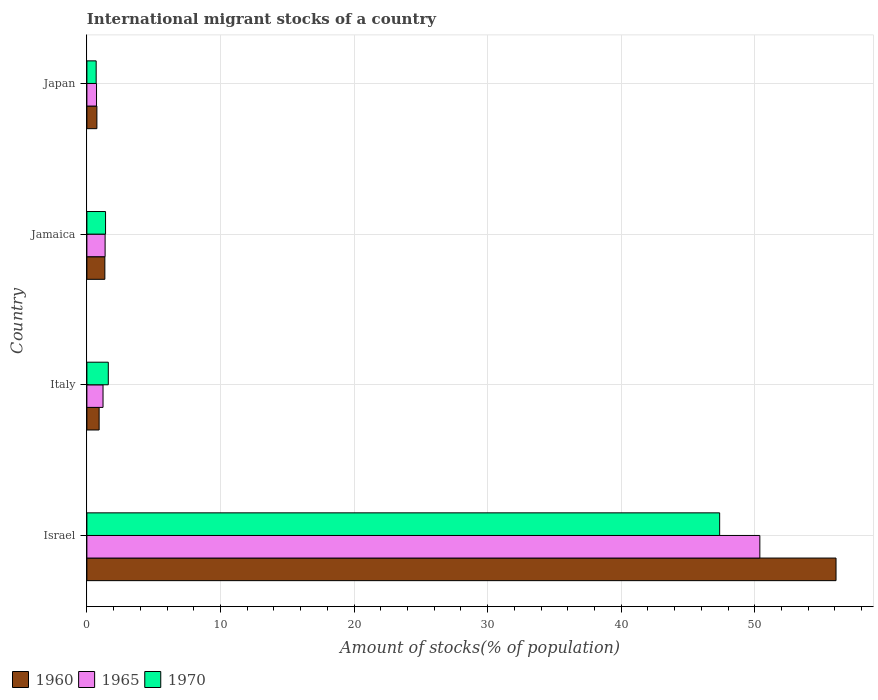How many different coloured bars are there?
Make the answer very short. 3. How many bars are there on the 2nd tick from the top?
Give a very brief answer. 3. How many bars are there on the 2nd tick from the bottom?
Make the answer very short. 3. What is the amount of stocks in in 1970 in Jamaica?
Offer a terse response. 1.4. Across all countries, what is the maximum amount of stocks in in 1965?
Offer a terse response. 50.38. Across all countries, what is the minimum amount of stocks in in 1970?
Provide a succinct answer. 0.69. In which country was the amount of stocks in in 1965 minimum?
Offer a very short reply. Japan. What is the total amount of stocks in in 1970 in the graph?
Offer a very short reply. 51.06. What is the difference between the amount of stocks in in 1970 in Italy and that in Jamaica?
Offer a terse response. 0.21. What is the difference between the amount of stocks in in 1965 in Italy and the amount of stocks in in 1970 in Jamaica?
Offer a very short reply. -0.19. What is the average amount of stocks in in 1960 per country?
Make the answer very short. 14.77. What is the difference between the amount of stocks in in 1965 and amount of stocks in in 1970 in Italy?
Offer a very short reply. -0.39. What is the ratio of the amount of stocks in in 1970 in Italy to that in Japan?
Give a very brief answer. 2.31. Is the difference between the amount of stocks in in 1965 in Italy and Japan greater than the difference between the amount of stocks in in 1970 in Italy and Japan?
Keep it short and to the point. No. What is the difference between the highest and the second highest amount of stocks in in 1970?
Provide a short and direct response. 45.77. What is the difference between the highest and the lowest amount of stocks in in 1965?
Your answer should be very brief. 49.66. Is the sum of the amount of stocks in in 1965 in Italy and Jamaica greater than the maximum amount of stocks in in 1960 across all countries?
Offer a terse response. No. What does the 1st bar from the bottom in Israel represents?
Provide a short and direct response. 1960. Is it the case that in every country, the sum of the amount of stocks in in 1965 and amount of stocks in in 1970 is greater than the amount of stocks in in 1960?
Keep it short and to the point. Yes. What is the difference between two consecutive major ticks on the X-axis?
Give a very brief answer. 10. Are the values on the major ticks of X-axis written in scientific E-notation?
Your response must be concise. No. Does the graph contain any zero values?
Make the answer very short. No. Does the graph contain grids?
Give a very brief answer. Yes. Where does the legend appear in the graph?
Offer a terse response. Bottom left. How many legend labels are there?
Make the answer very short. 3. How are the legend labels stacked?
Your response must be concise. Horizontal. What is the title of the graph?
Your response must be concise. International migrant stocks of a country. What is the label or title of the X-axis?
Offer a terse response. Amount of stocks(% of population). What is the Amount of stocks(% of population) of 1960 in Israel?
Your answer should be very brief. 56.08. What is the Amount of stocks(% of population) in 1965 in Israel?
Your answer should be very brief. 50.38. What is the Amount of stocks(% of population) in 1970 in Israel?
Make the answer very short. 47.37. What is the Amount of stocks(% of population) in 1960 in Italy?
Provide a succinct answer. 0.92. What is the Amount of stocks(% of population) in 1965 in Italy?
Your answer should be compact. 1.21. What is the Amount of stocks(% of population) of 1970 in Italy?
Your answer should be compact. 1.6. What is the Amount of stocks(% of population) in 1960 in Jamaica?
Your answer should be very brief. 1.34. What is the Amount of stocks(% of population) in 1965 in Jamaica?
Ensure brevity in your answer.  1.36. What is the Amount of stocks(% of population) in 1970 in Jamaica?
Offer a very short reply. 1.4. What is the Amount of stocks(% of population) in 1960 in Japan?
Offer a terse response. 0.75. What is the Amount of stocks(% of population) in 1965 in Japan?
Keep it short and to the point. 0.72. What is the Amount of stocks(% of population) of 1970 in Japan?
Your answer should be very brief. 0.69. Across all countries, what is the maximum Amount of stocks(% of population) in 1960?
Ensure brevity in your answer.  56.08. Across all countries, what is the maximum Amount of stocks(% of population) in 1965?
Provide a succinct answer. 50.38. Across all countries, what is the maximum Amount of stocks(% of population) of 1970?
Your response must be concise. 47.37. Across all countries, what is the minimum Amount of stocks(% of population) of 1960?
Your answer should be very brief. 0.75. Across all countries, what is the minimum Amount of stocks(% of population) in 1965?
Your answer should be compact. 0.72. Across all countries, what is the minimum Amount of stocks(% of population) of 1970?
Provide a short and direct response. 0.69. What is the total Amount of stocks(% of population) of 1960 in the graph?
Your answer should be very brief. 59.09. What is the total Amount of stocks(% of population) in 1965 in the graph?
Your answer should be very brief. 53.67. What is the total Amount of stocks(% of population) of 1970 in the graph?
Your answer should be compact. 51.06. What is the difference between the Amount of stocks(% of population) of 1960 in Israel and that in Italy?
Provide a short and direct response. 55.17. What is the difference between the Amount of stocks(% of population) of 1965 in Israel and that in Italy?
Your answer should be compact. 49.17. What is the difference between the Amount of stocks(% of population) of 1970 in Israel and that in Italy?
Offer a terse response. 45.77. What is the difference between the Amount of stocks(% of population) in 1960 in Israel and that in Jamaica?
Make the answer very short. 54.74. What is the difference between the Amount of stocks(% of population) in 1965 in Israel and that in Jamaica?
Give a very brief answer. 49.01. What is the difference between the Amount of stocks(% of population) in 1970 in Israel and that in Jamaica?
Offer a very short reply. 45.97. What is the difference between the Amount of stocks(% of population) in 1960 in Israel and that in Japan?
Keep it short and to the point. 55.33. What is the difference between the Amount of stocks(% of population) in 1965 in Israel and that in Japan?
Offer a terse response. 49.66. What is the difference between the Amount of stocks(% of population) in 1970 in Israel and that in Japan?
Ensure brevity in your answer.  46.67. What is the difference between the Amount of stocks(% of population) of 1960 in Italy and that in Jamaica?
Provide a succinct answer. -0.43. What is the difference between the Amount of stocks(% of population) of 1965 in Italy and that in Jamaica?
Keep it short and to the point. -0.16. What is the difference between the Amount of stocks(% of population) of 1970 in Italy and that in Jamaica?
Provide a succinct answer. 0.21. What is the difference between the Amount of stocks(% of population) of 1960 in Italy and that in Japan?
Offer a very short reply. 0.17. What is the difference between the Amount of stocks(% of population) of 1965 in Italy and that in Japan?
Your answer should be very brief. 0.49. What is the difference between the Amount of stocks(% of population) of 1970 in Italy and that in Japan?
Ensure brevity in your answer.  0.91. What is the difference between the Amount of stocks(% of population) of 1960 in Jamaica and that in Japan?
Provide a succinct answer. 0.6. What is the difference between the Amount of stocks(% of population) in 1965 in Jamaica and that in Japan?
Offer a terse response. 0.64. What is the difference between the Amount of stocks(% of population) of 1970 in Jamaica and that in Japan?
Keep it short and to the point. 0.7. What is the difference between the Amount of stocks(% of population) in 1960 in Israel and the Amount of stocks(% of population) in 1965 in Italy?
Provide a short and direct response. 54.87. What is the difference between the Amount of stocks(% of population) of 1960 in Israel and the Amount of stocks(% of population) of 1970 in Italy?
Offer a very short reply. 54.48. What is the difference between the Amount of stocks(% of population) of 1965 in Israel and the Amount of stocks(% of population) of 1970 in Italy?
Make the answer very short. 48.78. What is the difference between the Amount of stocks(% of population) of 1960 in Israel and the Amount of stocks(% of population) of 1965 in Jamaica?
Offer a terse response. 54.72. What is the difference between the Amount of stocks(% of population) of 1960 in Israel and the Amount of stocks(% of population) of 1970 in Jamaica?
Give a very brief answer. 54.69. What is the difference between the Amount of stocks(% of population) of 1965 in Israel and the Amount of stocks(% of population) of 1970 in Jamaica?
Keep it short and to the point. 48.98. What is the difference between the Amount of stocks(% of population) of 1960 in Israel and the Amount of stocks(% of population) of 1965 in Japan?
Make the answer very short. 55.36. What is the difference between the Amount of stocks(% of population) of 1960 in Israel and the Amount of stocks(% of population) of 1970 in Japan?
Provide a short and direct response. 55.39. What is the difference between the Amount of stocks(% of population) in 1965 in Israel and the Amount of stocks(% of population) in 1970 in Japan?
Make the answer very short. 49.68. What is the difference between the Amount of stocks(% of population) of 1960 in Italy and the Amount of stocks(% of population) of 1965 in Jamaica?
Give a very brief answer. -0.45. What is the difference between the Amount of stocks(% of population) of 1960 in Italy and the Amount of stocks(% of population) of 1970 in Jamaica?
Give a very brief answer. -0.48. What is the difference between the Amount of stocks(% of population) of 1965 in Italy and the Amount of stocks(% of population) of 1970 in Jamaica?
Your answer should be very brief. -0.19. What is the difference between the Amount of stocks(% of population) of 1960 in Italy and the Amount of stocks(% of population) of 1965 in Japan?
Make the answer very short. 0.19. What is the difference between the Amount of stocks(% of population) of 1960 in Italy and the Amount of stocks(% of population) of 1970 in Japan?
Your answer should be compact. 0.22. What is the difference between the Amount of stocks(% of population) of 1965 in Italy and the Amount of stocks(% of population) of 1970 in Japan?
Keep it short and to the point. 0.51. What is the difference between the Amount of stocks(% of population) of 1960 in Jamaica and the Amount of stocks(% of population) of 1965 in Japan?
Offer a terse response. 0.62. What is the difference between the Amount of stocks(% of population) of 1960 in Jamaica and the Amount of stocks(% of population) of 1970 in Japan?
Offer a terse response. 0.65. What is the difference between the Amount of stocks(% of population) of 1965 in Jamaica and the Amount of stocks(% of population) of 1970 in Japan?
Offer a terse response. 0.67. What is the average Amount of stocks(% of population) of 1960 per country?
Ensure brevity in your answer.  14.77. What is the average Amount of stocks(% of population) of 1965 per country?
Keep it short and to the point. 13.42. What is the average Amount of stocks(% of population) in 1970 per country?
Keep it short and to the point. 12.77. What is the difference between the Amount of stocks(% of population) of 1960 and Amount of stocks(% of population) of 1965 in Israel?
Your answer should be very brief. 5.7. What is the difference between the Amount of stocks(% of population) of 1960 and Amount of stocks(% of population) of 1970 in Israel?
Make the answer very short. 8.71. What is the difference between the Amount of stocks(% of population) of 1965 and Amount of stocks(% of population) of 1970 in Israel?
Your response must be concise. 3.01. What is the difference between the Amount of stocks(% of population) of 1960 and Amount of stocks(% of population) of 1965 in Italy?
Make the answer very short. -0.29. What is the difference between the Amount of stocks(% of population) of 1960 and Amount of stocks(% of population) of 1970 in Italy?
Your answer should be very brief. -0.69. What is the difference between the Amount of stocks(% of population) of 1965 and Amount of stocks(% of population) of 1970 in Italy?
Offer a very short reply. -0.39. What is the difference between the Amount of stocks(% of population) in 1960 and Amount of stocks(% of population) in 1965 in Jamaica?
Give a very brief answer. -0.02. What is the difference between the Amount of stocks(% of population) of 1960 and Amount of stocks(% of population) of 1970 in Jamaica?
Your answer should be very brief. -0.05. What is the difference between the Amount of stocks(% of population) of 1965 and Amount of stocks(% of population) of 1970 in Jamaica?
Keep it short and to the point. -0.03. What is the difference between the Amount of stocks(% of population) of 1960 and Amount of stocks(% of population) of 1965 in Japan?
Provide a succinct answer. 0.03. What is the difference between the Amount of stocks(% of population) in 1960 and Amount of stocks(% of population) in 1970 in Japan?
Make the answer very short. 0.05. What is the difference between the Amount of stocks(% of population) in 1965 and Amount of stocks(% of population) in 1970 in Japan?
Offer a very short reply. 0.03. What is the ratio of the Amount of stocks(% of population) in 1960 in Israel to that in Italy?
Make the answer very short. 61.26. What is the ratio of the Amount of stocks(% of population) of 1965 in Israel to that in Italy?
Your answer should be very brief. 41.7. What is the ratio of the Amount of stocks(% of population) in 1970 in Israel to that in Italy?
Your response must be concise. 29.56. What is the ratio of the Amount of stocks(% of population) in 1960 in Israel to that in Jamaica?
Give a very brief answer. 41.71. What is the ratio of the Amount of stocks(% of population) in 1965 in Israel to that in Jamaica?
Your response must be concise. 36.95. What is the ratio of the Amount of stocks(% of population) of 1970 in Israel to that in Jamaica?
Offer a very short reply. 33.92. What is the ratio of the Amount of stocks(% of population) in 1960 in Israel to that in Japan?
Make the answer very short. 74.89. What is the ratio of the Amount of stocks(% of population) in 1965 in Israel to that in Japan?
Provide a short and direct response. 69.88. What is the ratio of the Amount of stocks(% of population) of 1970 in Israel to that in Japan?
Your answer should be compact. 68.16. What is the ratio of the Amount of stocks(% of population) of 1960 in Italy to that in Jamaica?
Provide a succinct answer. 0.68. What is the ratio of the Amount of stocks(% of population) in 1965 in Italy to that in Jamaica?
Your answer should be very brief. 0.89. What is the ratio of the Amount of stocks(% of population) in 1970 in Italy to that in Jamaica?
Give a very brief answer. 1.15. What is the ratio of the Amount of stocks(% of population) of 1960 in Italy to that in Japan?
Your answer should be compact. 1.22. What is the ratio of the Amount of stocks(% of population) of 1965 in Italy to that in Japan?
Offer a terse response. 1.68. What is the ratio of the Amount of stocks(% of population) in 1970 in Italy to that in Japan?
Make the answer very short. 2.31. What is the ratio of the Amount of stocks(% of population) in 1960 in Jamaica to that in Japan?
Your response must be concise. 1.8. What is the ratio of the Amount of stocks(% of population) of 1965 in Jamaica to that in Japan?
Keep it short and to the point. 1.89. What is the ratio of the Amount of stocks(% of population) in 1970 in Jamaica to that in Japan?
Ensure brevity in your answer.  2.01. What is the difference between the highest and the second highest Amount of stocks(% of population) in 1960?
Your answer should be very brief. 54.74. What is the difference between the highest and the second highest Amount of stocks(% of population) of 1965?
Provide a succinct answer. 49.01. What is the difference between the highest and the second highest Amount of stocks(% of population) of 1970?
Give a very brief answer. 45.77. What is the difference between the highest and the lowest Amount of stocks(% of population) of 1960?
Your response must be concise. 55.33. What is the difference between the highest and the lowest Amount of stocks(% of population) of 1965?
Provide a succinct answer. 49.66. What is the difference between the highest and the lowest Amount of stocks(% of population) in 1970?
Provide a succinct answer. 46.67. 